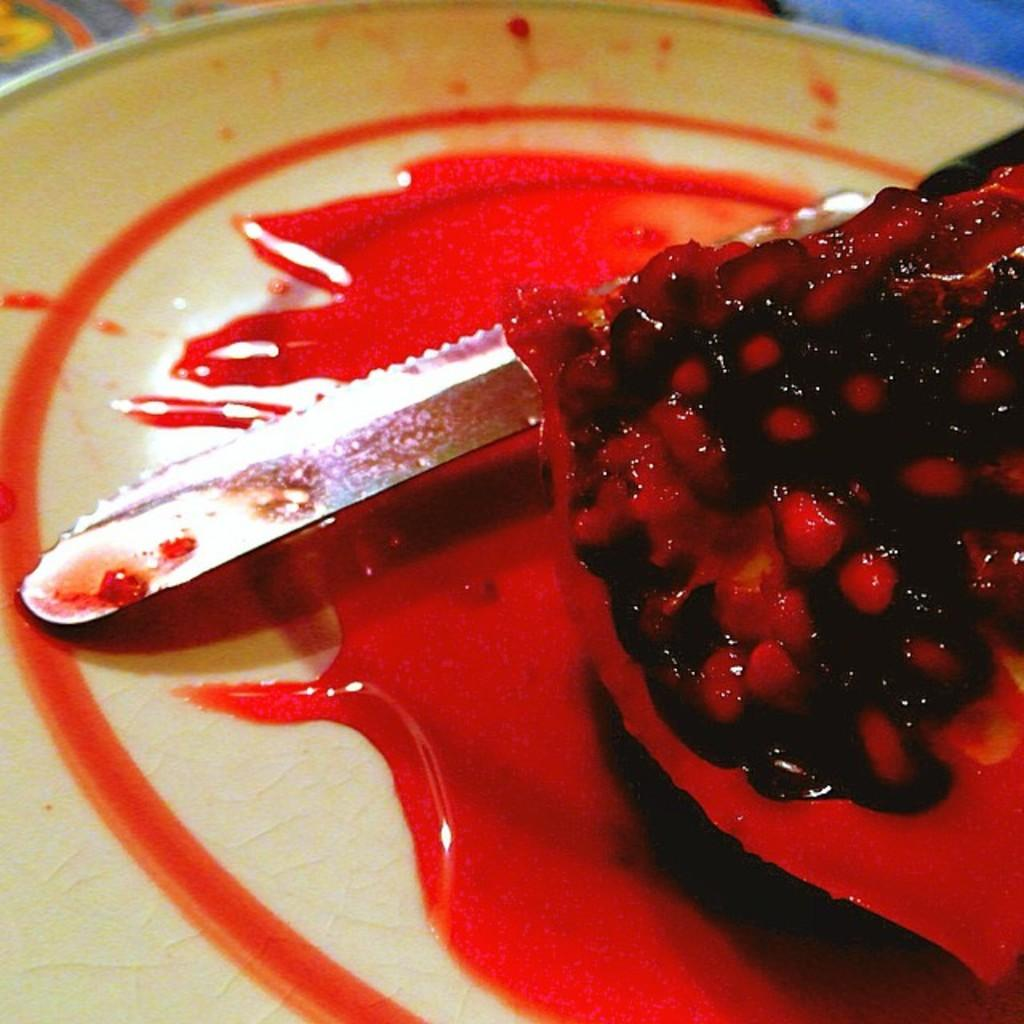What type of fruit is in the image? There is a pomegranate in the image. What tool is present in the image? There is a knife in the image. Where are the pomegranate and knife located? The pomegranate and knife are on a plate. What month is depicted on the calendar in the image? There is no calendar present in the image. What type of coastline can be seen in the image? There is no coastline present in the image. 